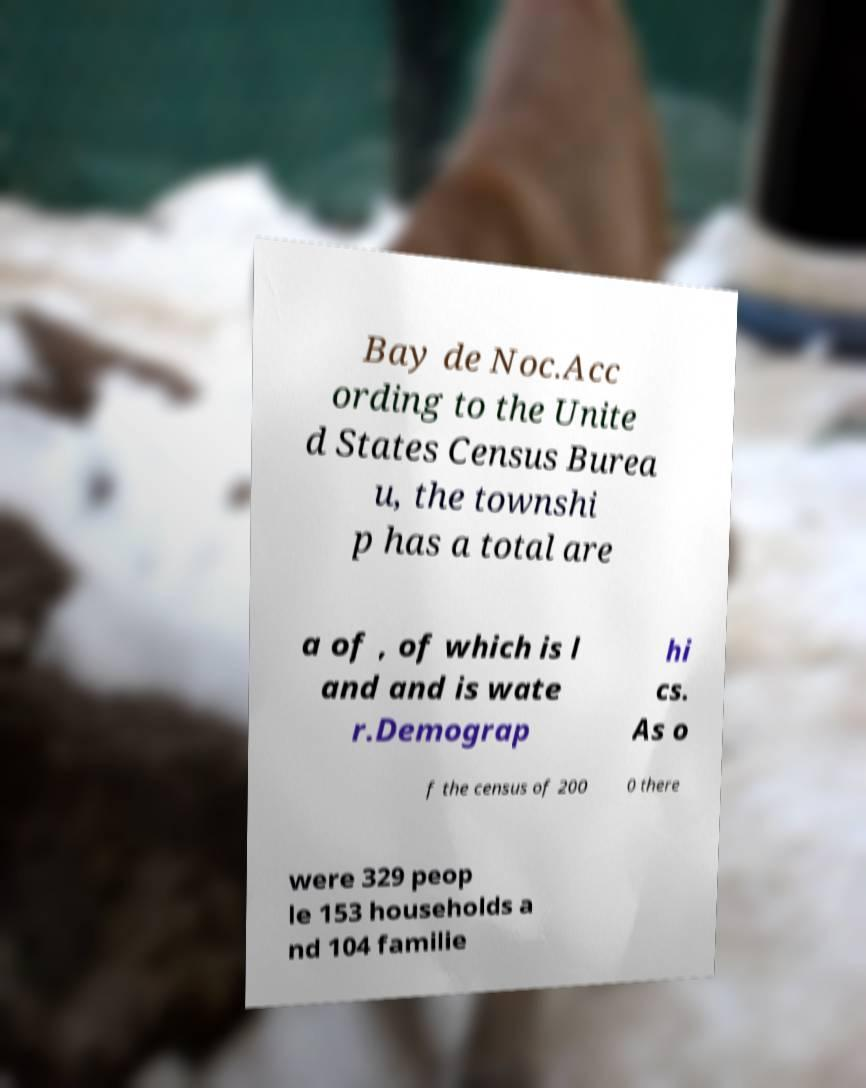What messages or text are displayed in this image? I need them in a readable, typed format. Bay de Noc.Acc ording to the Unite d States Census Burea u, the townshi p has a total are a of , of which is l and and is wate r.Demograp hi cs. As o f the census of 200 0 there were 329 peop le 153 households a nd 104 familie 